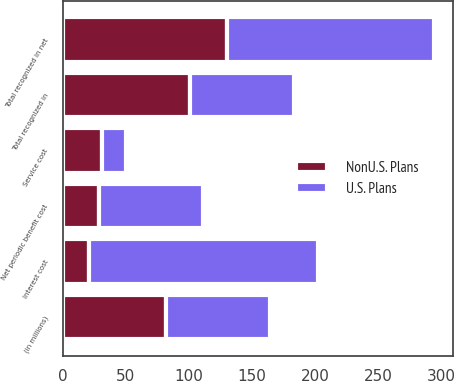<chart> <loc_0><loc_0><loc_500><loc_500><stacked_bar_chart><ecel><fcel>(in millions)<fcel>Service cost<fcel>Interest cost<fcel>Net periodic benefit cost<fcel>Total recognized in<fcel>Total recognized in net<nl><fcel>U.S. Plans<fcel>82<fcel>19<fcel>181<fcel>82<fcel>82<fcel>164<nl><fcel>NonU.S. Plans<fcel>82<fcel>31<fcel>21<fcel>29<fcel>101<fcel>130<nl></chart> 